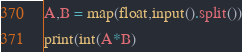Convert code to text. <code><loc_0><loc_0><loc_500><loc_500><_Python_>A,B = map(float,input().split())
print(int(A*B)</code> 